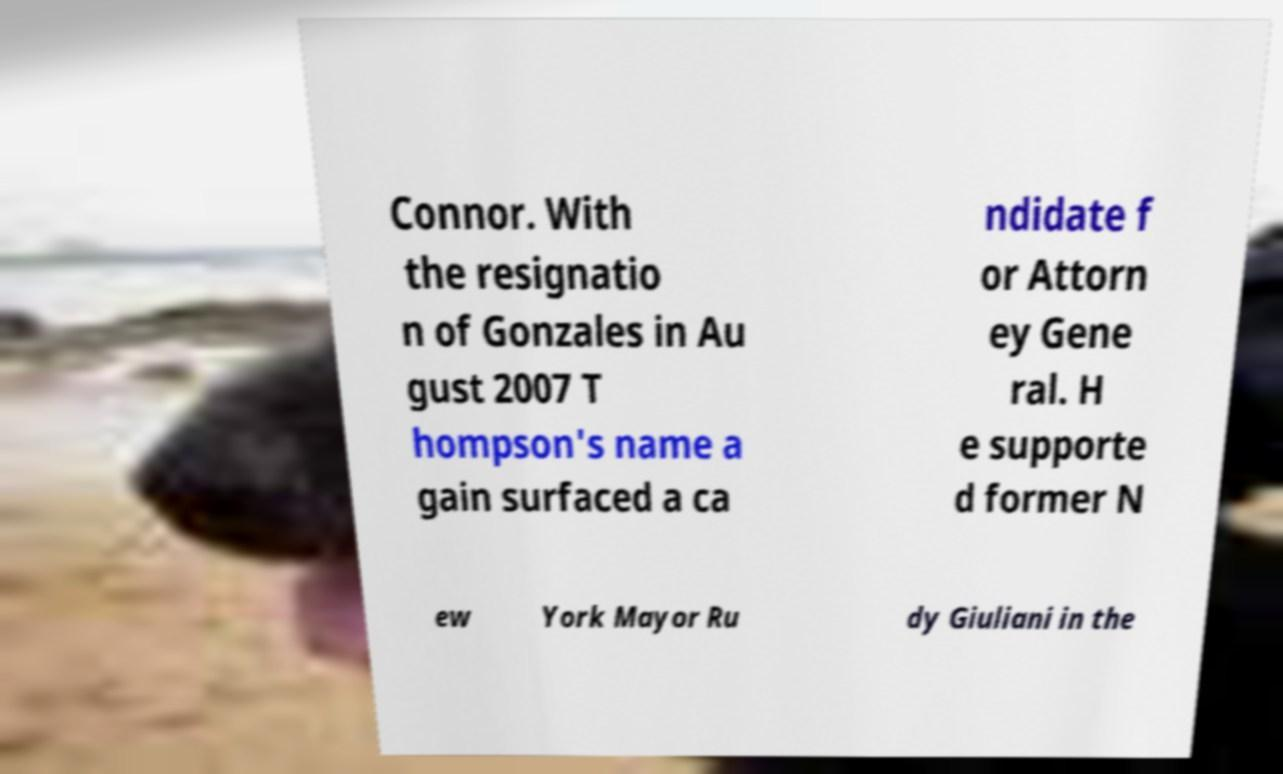Can you accurately transcribe the text from the provided image for me? Connor. With the resignatio n of Gonzales in Au gust 2007 T hompson's name a gain surfaced a ca ndidate f or Attorn ey Gene ral. H e supporte d former N ew York Mayor Ru dy Giuliani in the 